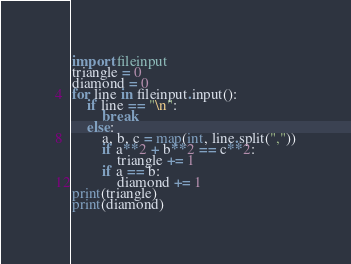Convert code to text. <code><loc_0><loc_0><loc_500><loc_500><_Python_>import fileinput
triangle = 0
diamond = 0
for line in fileinput.input():
    if line == "\n":
        break
    else:
        a, b, c = map(int, line.split(","))
        if a**2 + b**2 == c**2:
            triangle += 1
        if a == b:
            diamond += 1
print(triangle)
print(diamond)</code> 